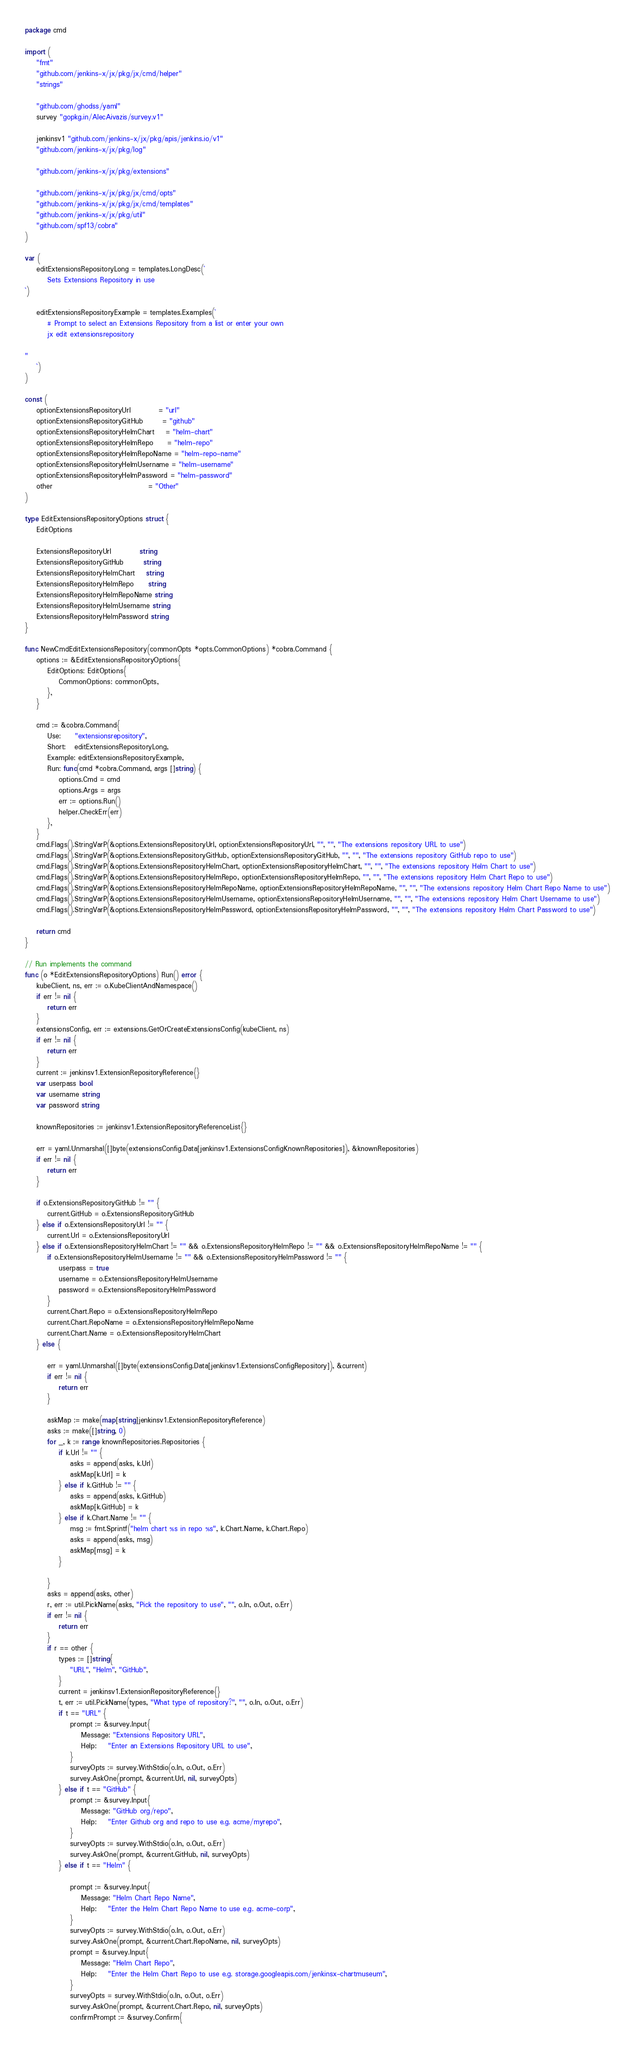<code> <loc_0><loc_0><loc_500><loc_500><_Go_>package cmd

import (
	"fmt"
	"github.com/jenkins-x/jx/pkg/jx/cmd/helper"
	"strings"

	"github.com/ghodss/yaml"
	survey "gopkg.in/AlecAivazis/survey.v1"

	jenkinsv1 "github.com/jenkins-x/jx/pkg/apis/jenkins.io/v1"
	"github.com/jenkins-x/jx/pkg/log"

	"github.com/jenkins-x/jx/pkg/extensions"

	"github.com/jenkins-x/jx/pkg/jx/cmd/opts"
	"github.com/jenkins-x/jx/pkg/jx/cmd/templates"
	"github.com/jenkins-x/jx/pkg/util"
	"github.com/spf13/cobra"
)

var (
	editExtensionsRepositoryLong = templates.LongDesc(`
		Sets Extensions Repository in use
`)

	editExtensionsRepositoryExample = templates.Examples(`
		# Prompt to select an Extensions Repository from a list or enter your own
		jx edit extensionsrepository

"
	`)
)

const (
	optionExtensionsRepositoryUrl          = "url"
	optionExtensionsRepositoryGitHub       = "github"
	optionExtensionsRepositoryHelmChart    = "helm-chart"
	optionExtensionsRepositoryHelmRepo     = "helm-repo"
	optionExtensionsRepositoryHelmRepoName = "helm-repo-name"
	optionExtensionsRepositoryHelmUsername = "helm-username"
	optionExtensionsRepositoryHelmPassword = "helm-password"
	other                                  = "Other"
)

type EditExtensionsRepositoryOptions struct {
	EditOptions

	ExtensionsRepositoryUrl          string
	ExtensionsRepositoryGitHub       string
	ExtensionsRepositoryHelmChart    string
	ExtensionsRepositoryHelmRepo     string
	ExtensionsRepositoryHelmRepoName string
	ExtensionsRepositoryHelmUsername string
	ExtensionsRepositoryHelmPassword string
}

func NewCmdEditExtensionsRepository(commonOpts *opts.CommonOptions) *cobra.Command {
	options := &EditExtensionsRepositoryOptions{
		EditOptions: EditOptions{
			CommonOptions: commonOpts,
		},
	}

	cmd := &cobra.Command{
		Use:     "extensionsrepository",
		Short:   editExtensionsRepositoryLong,
		Example: editExtensionsRepositoryExample,
		Run: func(cmd *cobra.Command, args []string) {
			options.Cmd = cmd
			options.Args = args
			err := options.Run()
			helper.CheckErr(err)
		},
	}
	cmd.Flags().StringVarP(&options.ExtensionsRepositoryUrl, optionExtensionsRepositoryUrl, "", "", "The extensions repository URL to use")
	cmd.Flags().StringVarP(&options.ExtensionsRepositoryGitHub, optionExtensionsRepositoryGitHub, "", "", "The extensions repository GitHub repo to use")
	cmd.Flags().StringVarP(&options.ExtensionsRepositoryHelmChart, optionExtensionsRepositoryHelmChart, "", "", "The extensions repository Helm Chart to use")
	cmd.Flags().StringVarP(&options.ExtensionsRepositoryHelmRepo, optionExtensionsRepositoryHelmRepo, "", "", "The extensions repository Helm Chart Repo to use")
	cmd.Flags().StringVarP(&options.ExtensionsRepositoryHelmRepoName, optionExtensionsRepositoryHelmRepoName, "", "", "The extensions repository Helm Chart Repo Name to use")
	cmd.Flags().StringVarP(&options.ExtensionsRepositoryHelmUsername, optionExtensionsRepositoryHelmUsername, "", "", "The extensions repository Helm Chart Username to use")
	cmd.Flags().StringVarP(&options.ExtensionsRepositoryHelmPassword, optionExtensionsRepositoryHelmPassword, "", "", "The extensions repository Helm Chart Password to use")

	return cmd
}

// Run implements the command
func (o *EditExtensionsRepositoryOptions) Run() error {
	kubeClient, ns, err := o.KubeClientAndNamespace()
	if err != nil {
		return err
	}
	extensionsConfig, err := extensions.GetOrCreateExtensionsConfig(kubeClient, ns)
	if err != nil {
		return err
	}
	current := jenkinsv1.ExtensionRepositoryReference{}
	var userpass bool
	var username string
	var password string

	knownRepositories := jenkinsv1.ExtensionRepositoryReferenceList{}

	err = yaml.Unmarshal([]byte(extensionsConfig.Data[jenkinsv1.ExtensionsConfigKnownRepositories]), &knownRepositories)
	if err != nil {
		return err
	}

	if o.ExtensionsRepositoryGitHub != "" {
		current.GitHub = o.ExtensionsRepositoryGitHub
	} else if o.ExtensionsRepositoryUrl != "" {
		current.Url = o.ExtensionsRepositoryUrl
	} else if o.ExtensionsRepositoryHelmChart != "" && o.ExtensionsRepositoryHelmRepo != "" && o.ExtensionsRepositoryHelmRepoName != "" {
		if o.ExtensionsRepositoryHelmUsername != "" && o.ExtensionsRepositoryHelmPassword != "" {
			userpass = true
			username = o.ExtensionsRepositoryHelmUsername
			password = o.ExtensionsRepositoryHelmPassword
		}
		current.Chart.Repo = o.ExtensionsRepositoryHelmRepo
		current.Chart.RepoName = o.ExtensionsRepositoryHelmRepoName
		current.Chart.Name = o.ExtensionsRepositoryHelmChart
	} else {

		err = yaml.Unmarshal([]byte(extensionsConfig.Data[jenkinsv1.ExtensionsConfigRepository]), &current)
		if err != nil {
			return err
		}

		askMap := make(map[string]jenkinsv1.ExtensionRepositoryReference)
		asks := make([]string, 0)
		for _, k := range knownRepositories.Repositories {
			if k.Url != "" {
				asks = append(asks, k.Url)
				askMap[k.Url] = k
			} else if k.GitHub != "" {
				asks = append(asks, k.GitHub)
				askMap[k.GitHub] = k
			} else if k.Chart.Name != "" {
				msg := fmt.Sprintf("helm chart %s in repo %s", k.Chart.Name, k.Chart.Repo)
				asks = append(asks, msg)
				askMap[msg] = k
			}

		}
		asks = append(asks, other)
		r, err := util.PickName(asks, "Pick the repository to use", "", o.In, o.Out, o.Err)
		if err != nil {
			return err
		}
		if r == other {
			types := []string{
				"URL", "Helm", "GitHub",
			}
			current = jenkinsv1.ExtensionRepositoryReference{}
			t, err := util.PickName(types, "What type of repository?", "", o.In, o.Out, o.Err)
			if t == "URL" {
				prompt := &survey.Input{
					Message: "Extensions Repository URL",
					Help:    "Enter an Extensions Repository URL to use",
				}
				surveyOpts := survey.WithStdio(o.In, o.Out, o.Err)
				survey.AskOne(prompt, &current.Url, nil, surveyOpts)
			} else if t == "GitHub" {
				prompt := &survey.Input{
					Message: "GitHub org/repo",
					Help:    "Enter Github org and repo to use e.g. acme/myrepo",
				}
				surveyOpts := survey.WithStdio(o.In, o.Out, o.Err)
				survey.AskOne(prompt, &current.GitHub, nil, surveyOpts)
			} else if t == "Helm" {

				prompt := &survey.Input{
					Message: "Helm Chart Repo Name",
					Help:    "Enter the Helm Chart Repo Name to use e.g. acme-corp",
				}
				surveyOpts := survey.WithStdio(o.In, o.Out, o.Err)
				survey.AskOne(prompt, &current.Chart.RepoName, nil, surveyOpts)
				prompt = &survey.Input{
					Message: "Helm Chart Repo",
					Help:    "Enter the Helm Chart Repo to use e.g. storage.googleapis.com/jenkinsx-chartmuseum",
				}
				surveyOpts = survey.WithStdio(o.In, o.Out, o.Err)
				survey.AskOne(prompt, &current.Chart.Repo, nil, surveyOpts)
				confirmPrompt := &survey.Confirm{</code> 